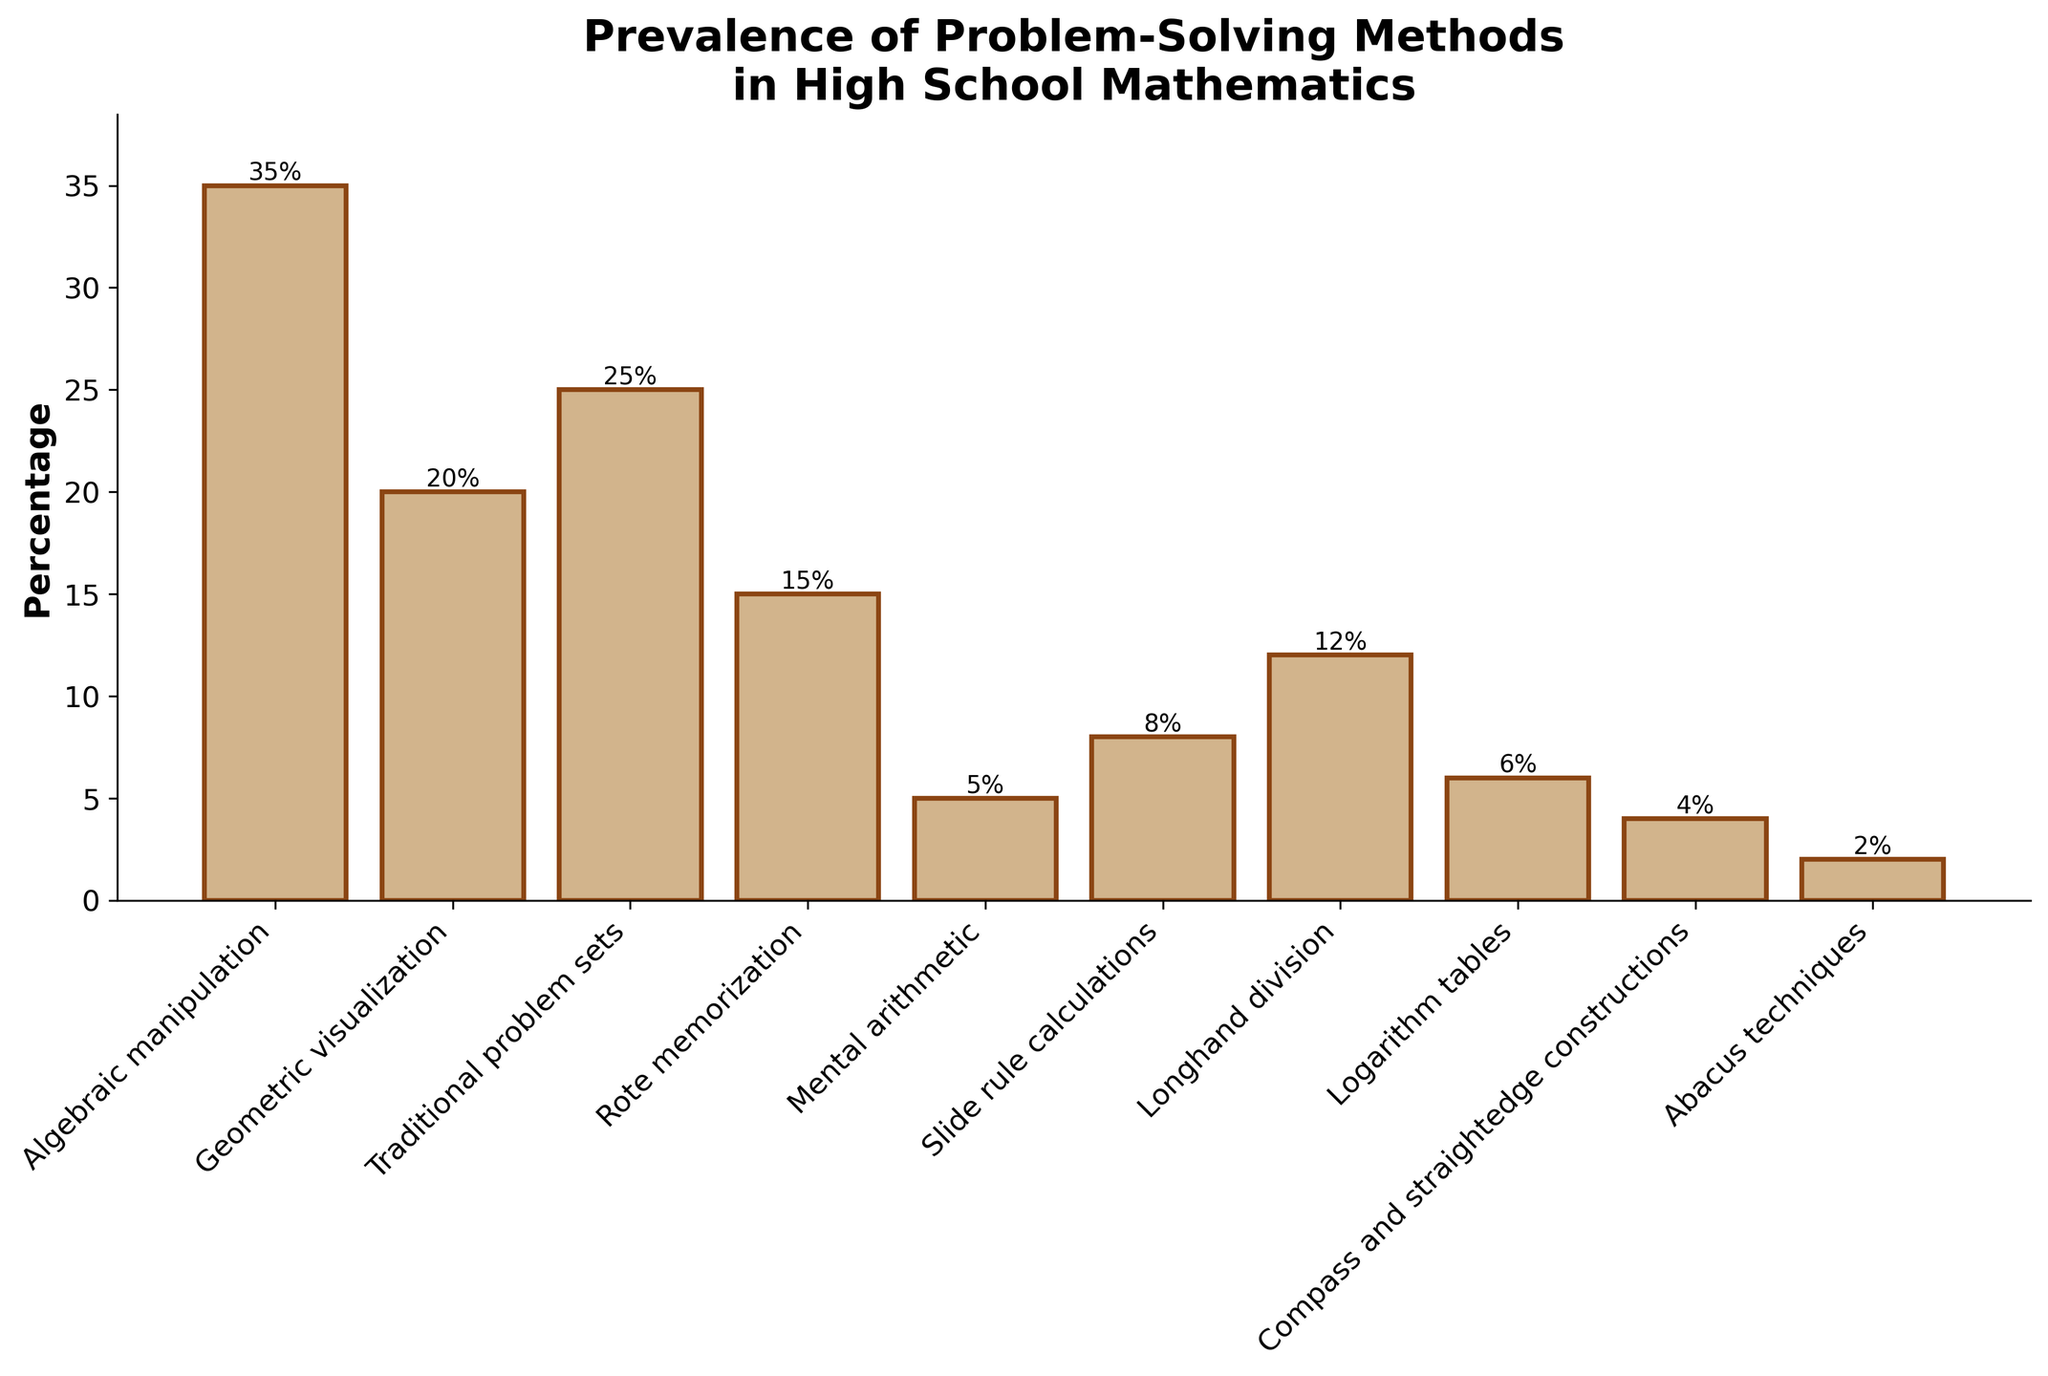What's the percentage of students taught algebraic manipulation compared to rote memorization? To find the percentage difference, look at the heights of the bars for algebraic manipulation and rote memorization. Algebraic manipulation is 35% and rote memorization is 15%. The difference is 35% - 15%.
Answer: 20% What is the sum of the percentages for slide rule calculations, logarithm tables, and abacus techniques? Add the percentages of these methods: 8% (slide rule calculations) + 6% (logarithm tables) + 2% (abacus techniques). So, the sum is 8% + 6% + 2%.
Answer: 16% Which problem-solving method is represented by the shortest bar? Identify the shortest bar by visual inspection, which corresponds to abacus techniques with a height of 2%.
Answer: Abacus techniques How many methods have a percentage lower than 10%? Count the bars that are less than 10% in height. These methods are mental arithmetic (5%), slide rule calculations (8%), logarithm tables (6%), compass and straightedge constructions (4%), and abacus techniques (2%).
Answer: 5 What's the average percentage of all mentioned problem-solving methods? Sum all the percentages and divide by the number of methods. The sum is 35% + 20% + 25% + 15% + 5% + 8% + 12% + 6% + 4% + 2% = 132%. Divide by 10 methods.
Answer: 13.2% Which methods have equal or higher percentage than the sum of logarithm tables and compass and straightedge constructions? Calculate the sum of logarithm tables and compass and straightedge constructions. 6% + 4% = 10%. Methods with percentages equal or higher: algebraic manipulation (35%), geometric visualization (20%), traditional problem sets (25%), rote memorization (15%), longhand division (12%).
Answer: Algebraic manipulation, Geometric visualization, Traditional problem sets, Rote memorization, Longhand division How much more prevalent is algebraic manipulation compared to geometric visualization? Look at the bar heights: algebraic manipulation is 35%, geometric visualization is 20%. Subtract geometric visualization from algebraic manipulation. 35% - 20%.
Answer: 15% What's the percentage difference between the most and least prevalent problem-solving methods? The most prevalent is algebraic manipulation (35%), and the least prevalent is abacus techniques (2%). The percentage difference is 35% - 2%.
Answer: 33% What are the methods with percentages between 10% and 20%? Identify bars with heights between 10% and 20%: traditional problem sets (25%) is above this range, longhand division (12%) is within this range.
Answer: Longhand division 